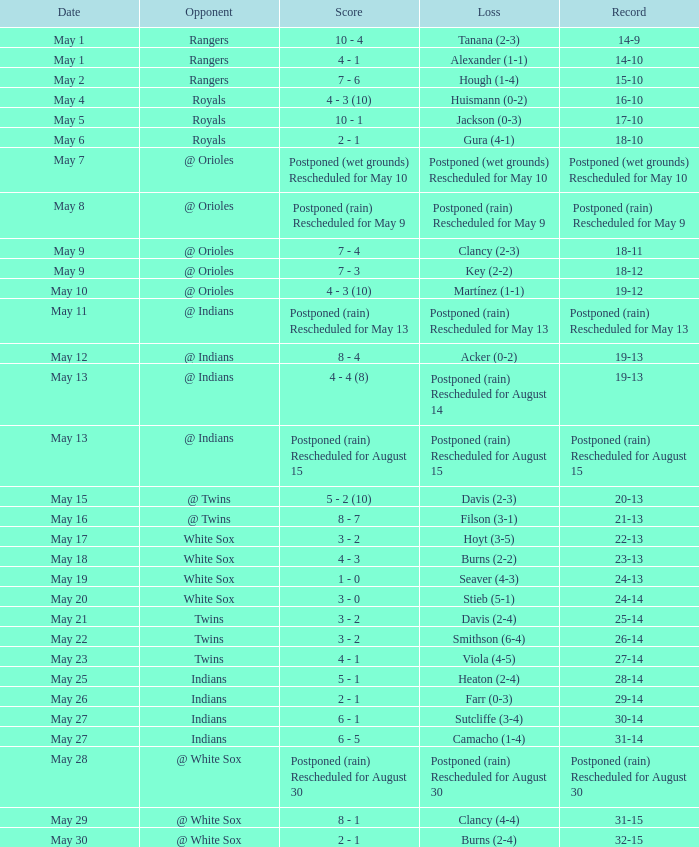Who was the opponent at the game when the record was 22-13? White Sox. I'm looking to parse the entire table for insights. Could you assist me with that? {'header': ['Date', 'Opponent', 'Score', 'Loss', 'Record'], 'rows': [['May 1', 'Rangers', '10 - 4', 'Tanana (2-3)', '14-9'], ['May 1', 'Rangers', '4 - 1', 'Alexander (1-1)', '14-10'], ['May 2', 'Rangers', '7 - 6', 'Hough (1-4)', '15-10'], ['May 4', 'Royals', '4 - 3 (10)', 'Huismann (0-2)', '16-10'], ['May 5', 'Royals', '10 - 1', 'Jackson (0-3)', '17-10'], ['May 6', 'Royals', '2 - 1', 'Gura (4-1)', '18-10'], ['May 7', '@ Orioles', 'Postponed (wet grounds) Rescheduled for May 10', 'Postponed (wet grounds) Rescheduled for May 10', 'Postponed (wet grounds) Rescheduled for May 10'], ['May 8', '@ Orioles', 'Postponed (rain) Rescheduled for May 9', 'Postponed (rain) Rescheduled for May 9', 'Postponed (rain) Rescheduled for May 9'], ['May 9', '@ Orioles', '7 - 4', 'Clancy (2-3)', '18-11'], ['May 9', '@ Orioles', '7 - 3', 'Key (2-2)', '18-12'], ['May 10', '@ Orioles', '4 - 3 (10)', 'Martínez (1-1)', '19-12'], ['May 11', '@ Indians', 'Postponed (rain) Rescheduled for May 13', 'Postponed (rain) Rescheduled for May 13', 'Postponed (rain) Rescheduled for May 13'], ['May 12', '@ Indians', '8 - 4', 'Acker (0-2)', '19-13'], ['May 13', '@ Indians', '4 - 4 (8)', 'Postponed (rain) Rescheduled for August 14', '19-13'], ['May 13', '@ Indians', 'Postponed (rain) Rescheduled for August 15', 'Postponed (rain) Rescheduled for August 15', 'Postponed (rain) Rescheduled for August 15'], ['May 15', '@ Twins', '5 - 2 (10)', 'Davis (2-3)', '20-13'], ['May 16', '@ Twins', '8 - 7', 'Filson (3-1)', '21-13'], ['May 17', 'White Sox', '3 - 2', 'Hoyt (3-5)', '22-13'], ['May 18', 'White Sox', '4 - 3', 'Burns (2-2)', '23-13'], ['May 19', 'White Sox', '1 - 0', 'Seaver (4-3)', '24-13'], ['May 20', 'White Sox', '3 - 0', 'Stieb (5-1)', '24-14'], ['May 21', 'Twins', '3 - 2', 'Davis (2-4)', '25-14'], ['May 22', 'Twins', '3 - 2', 'Smithson (6-4)', '26-14'], ['May 23', 'Twins', '4 - 1', 'Viola (4-5)', '27-14'], ['May 25', 'Indians', '5 - 1', 'Heaton (2-4)', '28-14'], ['May 26', 'Indians', '2 - 1', 'Farr (0-3)', '29-14'], ['May 27', 'Indians', '6 - 1', 'Sutcliffe (3-4)', '30-14'], ['May 27', 'Indians', '6 - 5', 'Camacho (1-4)', '31-14'], ['May 28', '@ White Sox', 'Postponed (rain) Rescheduled for August 30', 'Postponed (rain) Rescheduled for August 30', 'Postponed (rain) Rescheduled for August 30'], ['May 29', '@ White Sox', '8 - 1', 'Clancy (4-4)', '31-15'], ['May 30', '@ White Sox', '2 - 1', 'Burns (2-4)', '32-15']]} 